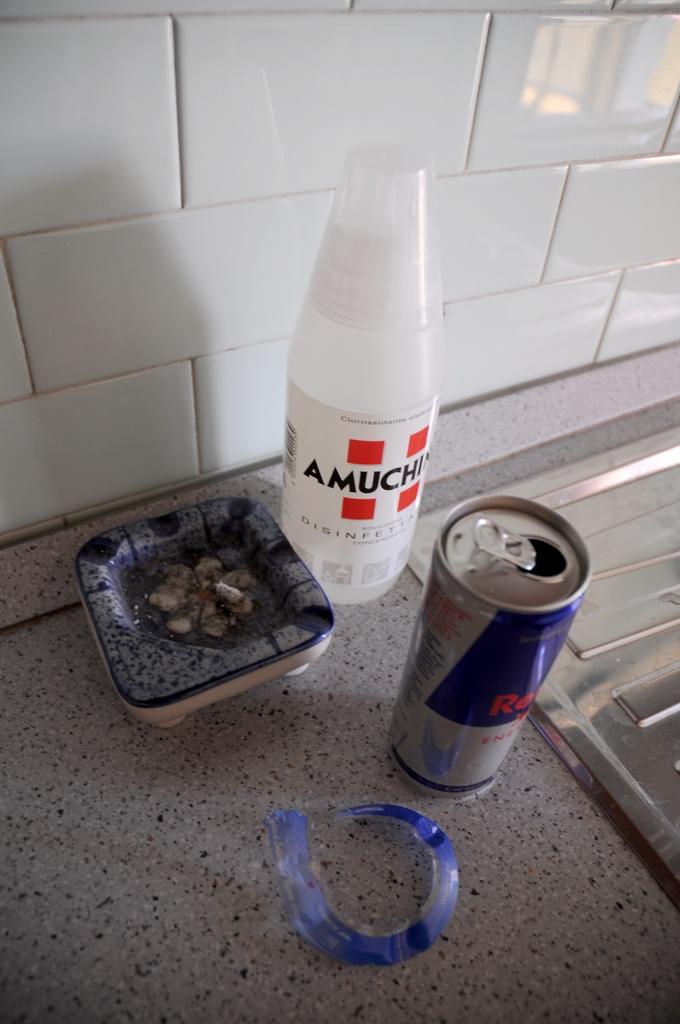Is that a can of redbull?
Offer a very short reply. Yes. Is there a disinfectant in the picture?
Offer a terse response. Yes. 